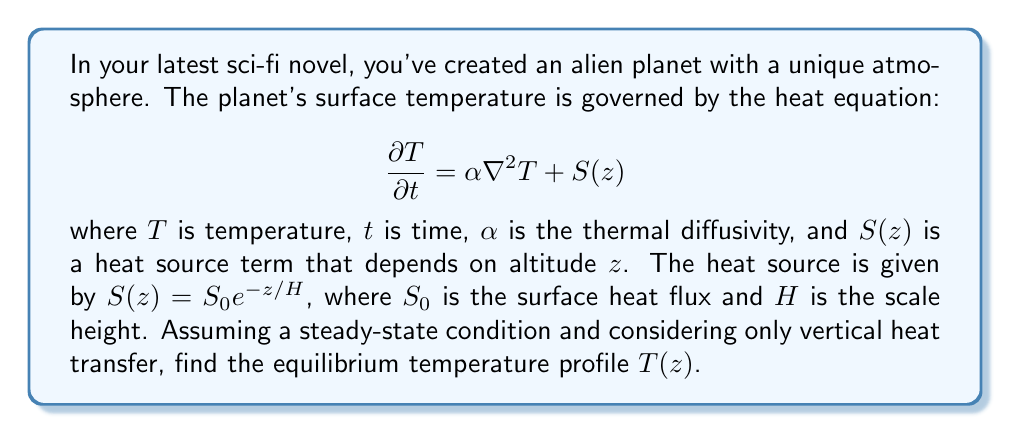What is the answer to this math problem? To solve this problem, we'll follow these steps:

1) In steady-state, the time derivative is zero: $\frac{\partial T}{\partial t} = 0$

2) Considering only vertical heat transfer, the Laplacian $\nabla^2$ reduces to $\frac{d^2}{dz^2}$

3) Our equation becomes:

   $$0 = \alpha \frac{d^2T}{dz^2} + S_0 e^{-z/H}$$

4) Rearrange:

   $$\frac{d^2T}{dz^2} = -\frac{S_0}{\alpha} e^{-z/H}$$

5) Integrate once:

   $$\frac{dT}{dz} = \frac{S_0 H}{\alpha} e^{-z/H} + C_1$$

6) Integrate again:

   $$T(z) = -\frac{S_0 H^2}{\alpha} e^{-z/H} + C_1z + C_2$$

7) To determine $C_1$ and $C_2$, we need boundary conditions. Let's assume:
   - At the surface ($z=0$), $T = T_0$
   - As $z \to \infty$, $\frac{dT}{dz} \to 0$ (temperature gradient approaches zero at great heights)

8) Applying the second condition to the equation from step 5:

   $$\lim_{z \to \infty} \frac{dT}{dz} = C_1 = 0$$

9) Applying the first condition to the equation from step 6:

   $$T_0 = -\frac{S_0 H^2}{\alpha} + C_2$$

   So, $C_2 = T_0 + \frac{S_0 H^2}{\alpha}$

10) The final temperature profile is:

    $$T(z) = T_0 + \frac{S_0 H^2}{\alpha}(1 - e^{-z/H})$$

This equation describes how the temperature changes with altitude in the alien atmosphere.
Answer: $T(z) = T_0 + \frac{S_0 H^2}{\alpha}(1 - e^{-z/H})$ 